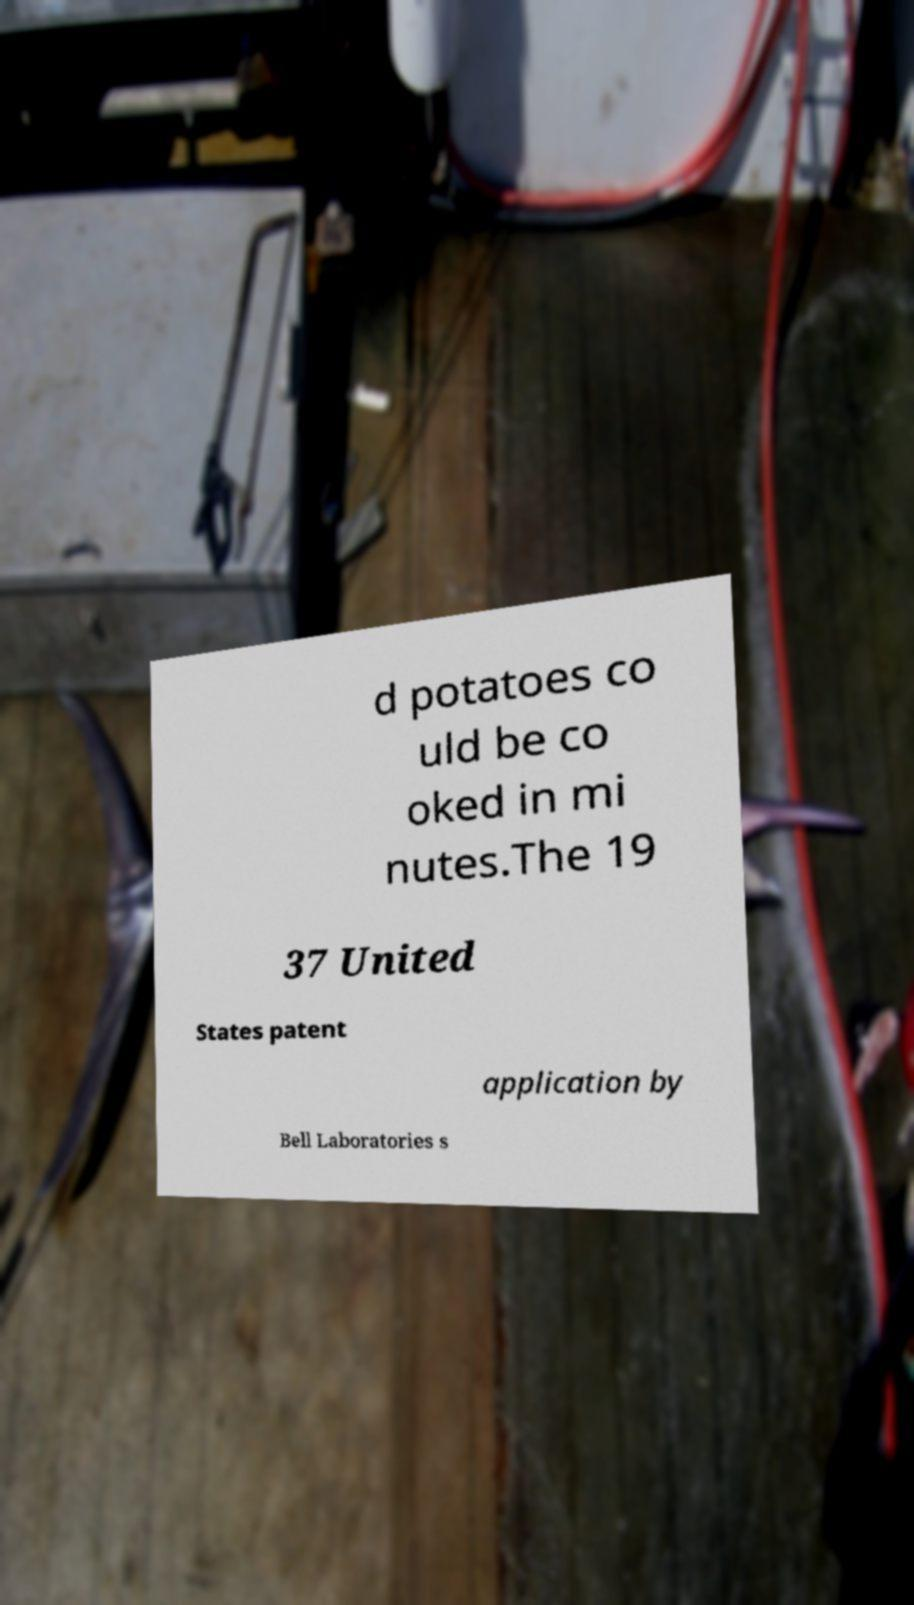Could you extract and type out the text from this image? d potatoes co uld be co oked in mi nutes.The 19 37 United States patent application by Bell Laboratories s 